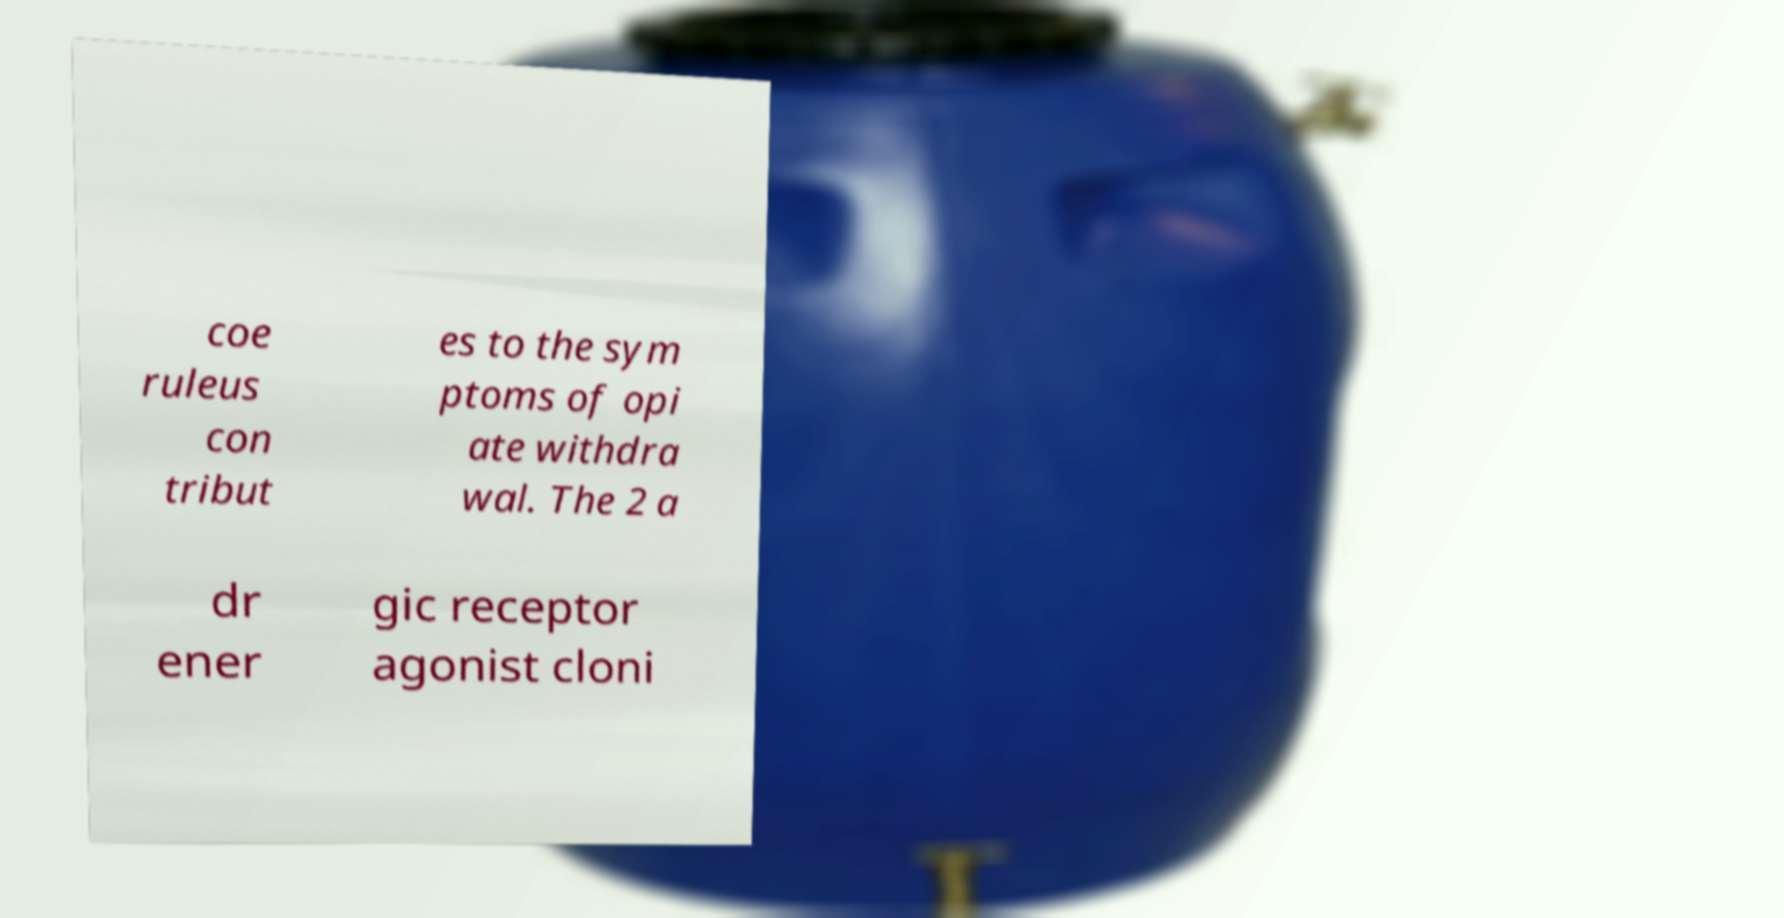There's text embedded in this image that I need extracted. Can you transcribe it verbatim? coe ruleus con tribut es to the sym ptoms of opi ate withdra wal. The 2 a dr ener gic receptor agonist cloni 